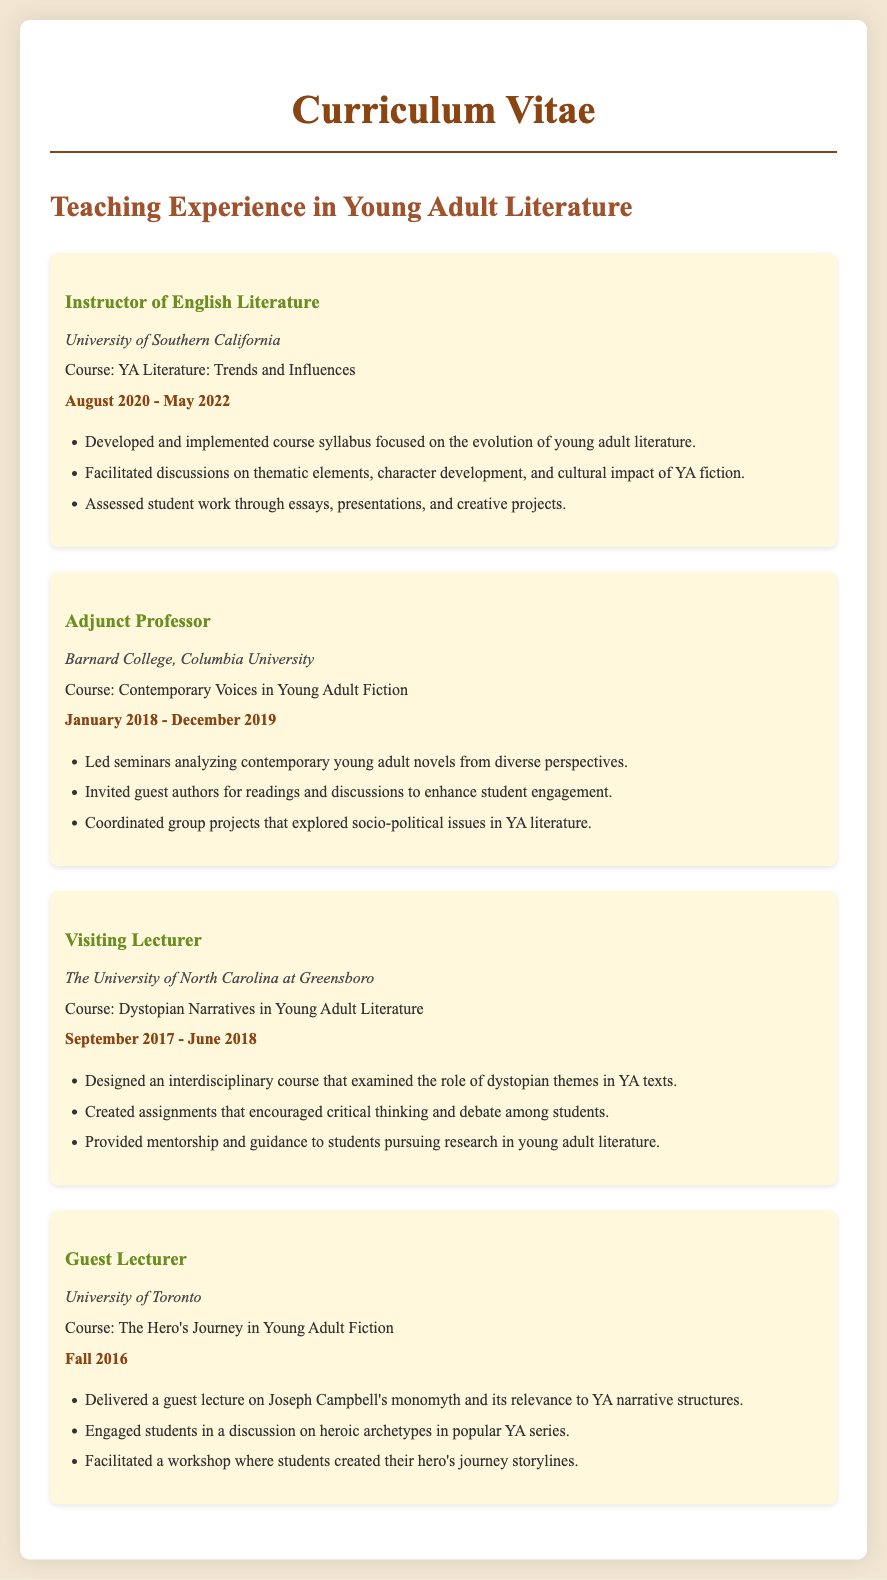What is the title of the course taught at the University of Southern California? The title of the course is listed under the relevant experience section for the University of Southern California.
Answer: YA Literature: Trends and Influences Who was the instructor at Barnard College? The document states the role of the individual teaching at Barnard College, which is mentioned in the experience section.
Answer: Adjunct Professor During which academic term was the course on The Hero's Journey conducted? The academic term is noted in the section for the course taught at the University of Toronto.
Answer: Fall 2016 What type of literature was explored in the course at The University of North Carolina at Greensboro? This information can be found in the description of the course taught at that institution focusing on specific themes.
Answer: Dystopian Narratives How long did the instructor teach Contemporary Voices in Young Adult Fiction? The duration is provided in the experience section for Barnard College, indicating the teaching timeline.
Answer: January 2018 - December 2019 Which university did the instructor guest lecture at? The guest lecturer's institution is mentioned in the corresponding section discussing their teaching experience.
Answer: University of Toronto What method did the instructor use to engage students in the course about YA literature at USC? The methods used are detailed in the course description for the relevant position at USC.
Answer: Facilitated discussions What role did the instructor have at The University of North Carolina at Greensboro? The role is clearly defined in the document regarding the teaching experience at that university.
Answer: Visiting Lecturer What literary focus was mentioned in the course taught at Barnard College? The focus of the course is specified in the experience description for Barnard College.
Answer: Contemporary young adult novels 